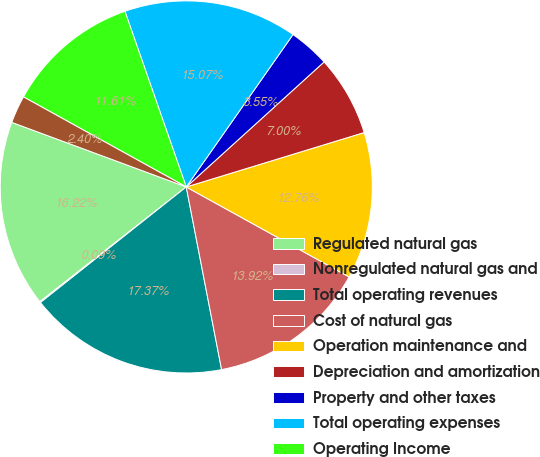<chart> <loc_0><loc_0><loc_500><loc_500><pie_chart><fcel>Regulated natural gas<fcel>Nonregulated natural gas and<fcel>Total operating revenues<fcel>Cost of natural gas<fcel>Operation maintenance and<fcel>Depreciation and amortization<fcel>Property and other taxes<fcel>Total operating expenses<fcel>Operating Income<fcel>Equity in (losses) earnings of<nl><fcel>16.22%<fcel>0.09%<fcel>17.37%<fcel>13.92%<fcel>12.76%<fcel>7.0%<fcel>3.55%<fcel>15.07%<fcel>11.61%<fcel>2.4%<nl></chart> 